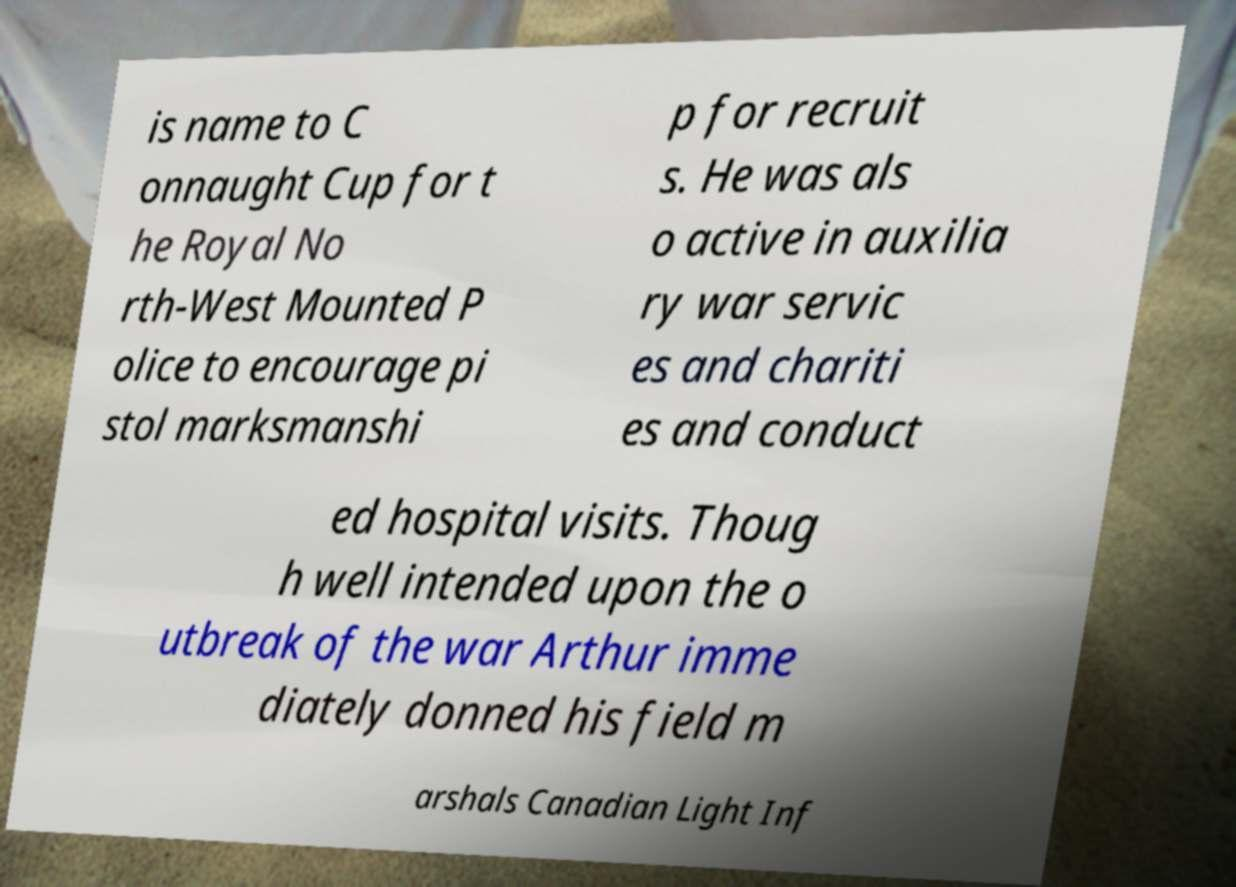Could you extract and type out the text from this image? is name to C onnaught Cup for t he Royal No rth-West Mounted P olice to encourage pi stol marksmanshi p for recruit s. He was als o active in auxilia ry war servic es and chariti es and conduct ed hospital visits. Thoug h well intended upon the o utbreak of the war Arthur imme diately donned his field m arshals Canadian Light Inf 